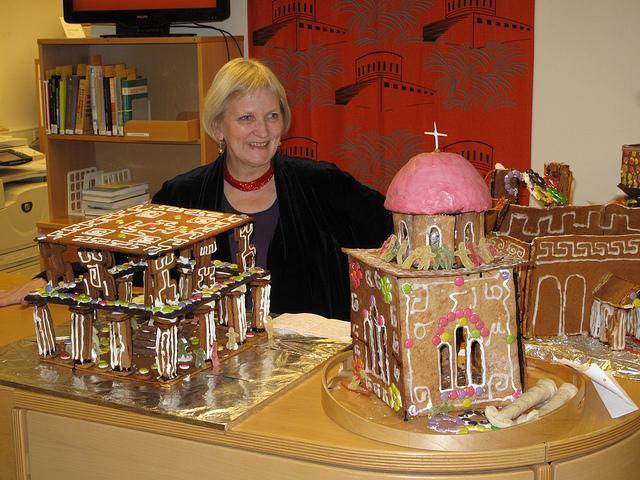How many cakes are there?
Give a very brief answer. 3. 